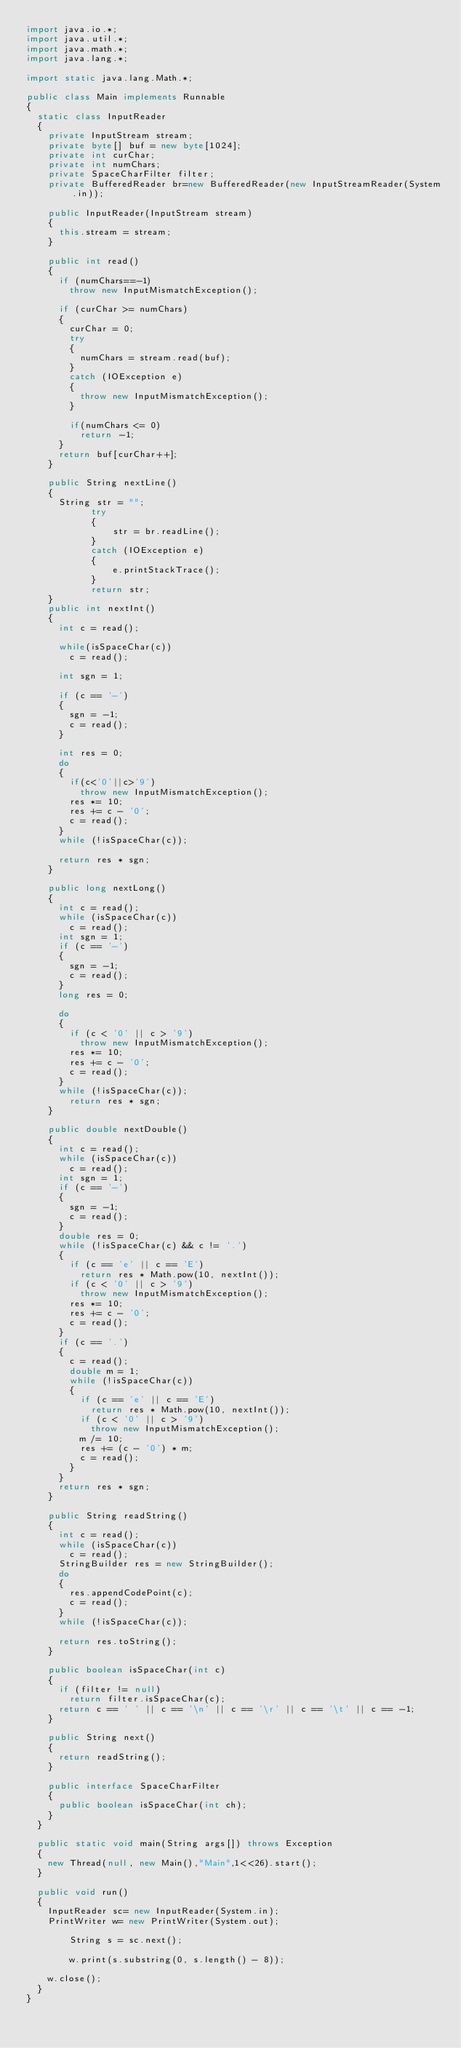Convert code to text. <code><loc_0><loc_0><loc_500><loc_500><_Java_>import java.io.*;
import java.util.*;
import java.math.*;
import java.lang.*;
 
import static java.lang.Math.*;
 
public class Main implements Runnable
{
	static class InputReader
	{
		private InputStream stream;
		private byte[] buf = new byte[1024];
		private int curChar;
		private int numChars;
		private SpaceCharFilter filter;
		private BufferedReader br=new BufferedReader(new InputStreamReader(System.in));

		public InputReader(InputStream stream)
		{
			this.stream = stream;
		}
		
		public int read()
		{
			if (numChars==-1) 
				throw new InputMismatchException();
			
			if (curChar >= numChars)
			{
				curChar = 0;
				try 
				{
					numChars = stream.read(buf);
				}
				catch (IOException e)
				{
					throw new InputMismatchException();
				}
				
				if(numChars <= 0)				
					return -1;
			}
			return buf[curChar++];
		}
	 
		public String nextLine()
		{
			String str = "";
            try
            {
                str = br.readLine();
            }
            catch (IOException e)
            {
                e.printStackTrace();
            }
            return str;
		}
		public int nextInt()
		{
			int c = read();
			
			while(isSpaceChar(c)) 
				c = read();
			
			int sgn = 1;
			
			if (c == '-') 
			{
				sgn = -1;
				c = read();
			}
			
			int res = 0;
			do 
			{
				if(c<'0'||c>'9') 
					throw new InputMismatchException();
				res *= 10;
				res += c - '0';
				c = read();
			}
			while (!isSpaceChar(c)); 
			
			return res * sgn;
		}
		
		public long nextLong() 
		{
			int c = read();
			while (isSpaceChar(c))
				c = read();
			int sgn = 1;
			if (c == '-') 
			{
				sgn = -1;
				c = read();
			}
			long res = 0;
			
			do 
			{
				if (c < '0' || c > '9')
					throw new InputMismatchException();
				res *= 10;
				res += c - '0';
				c = read();
			}
			while (!isSpaceChar(c));
				return res * sgn;
		}
		
		public double nextDouble() 
		{
			int c = read();
			while (isSpaceChar(c))
				c = read();
			int sgn = 1;
			if (c == '-') 
			{
				sgn = -1;
				c = read();
			}
			double res = 0;
			while (!isSpaceChar(c) && c != '.') 
			{
				if (c == 'e' || c == 'E')
					return res * Math.pow(10, nextInt());
				if (c < '0' || c > '9')
					throw new InputMismatchException();
				res *= 10;
				res += c - '0';
				c = read();
			}
			if (c == '.') 
			{
				c = read();
				double m = 1;
				while (!isSpaceChar(c)) 
				{
					if (c == 'e' || c == 'E')
						return res * Math.pow(10, nextInt());
					if (c < '0' || c > '9')
						throw new InputMismatchException();
					m /= 10;
					res += (c - '0') * m;
					c = read();
				}
			}
			return res * sgn;
		}
		
		public String readString() 
		{
			int c = read();
			while (isSpaceChar(c))
				c = read();
			StringBuilder res = new StringBuilder();
			do 
			{
				res.appendCodePoint(c);
				c = read();
			} 
			while (!isSpaceChar(c));
			
			return res.toString();
		}
	 
		public boolean isSpaceChar(int c) 
		{
			if (filter != null)
				return filter.isSpaceChar(c);
			return c == ' ' || c == '\n' || c == '\r' || c == '\t' || c == -1;
		}
	 
		public String next() 
		{
			return readString();
		}
		
		public interface SpaceCharFilter 
		{
			public boolean isSpaceChar(int ch);
		}
	}
 	
	public static void main(String args[]) throws Exception
	{
		new Thread(null, new Main(),"Main",1<<26).start();
	}
	
	public void run()
	{
		InputReader sc= new InputReader(System.in);
		PrintWriter w= new PrintWriter(System.out);
		
        String s = sc.next();
        
        w.print(s.substring(0, s.length() - 8));
        
		w.close();		
	}
}</code> 